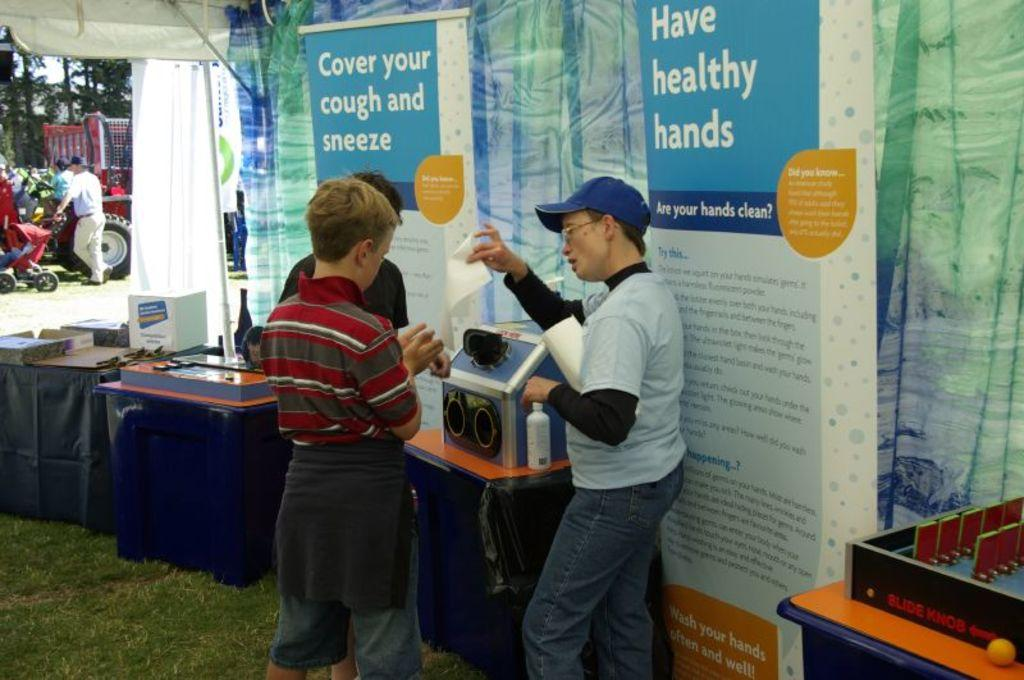<image>
Summarize the visual content of the image. People talking in front of a blue sign which says "Have healthy hands". 